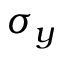<formula> <loc_0><loc_0><loc_500><loc_500>\sigma _ { y }</formula> 